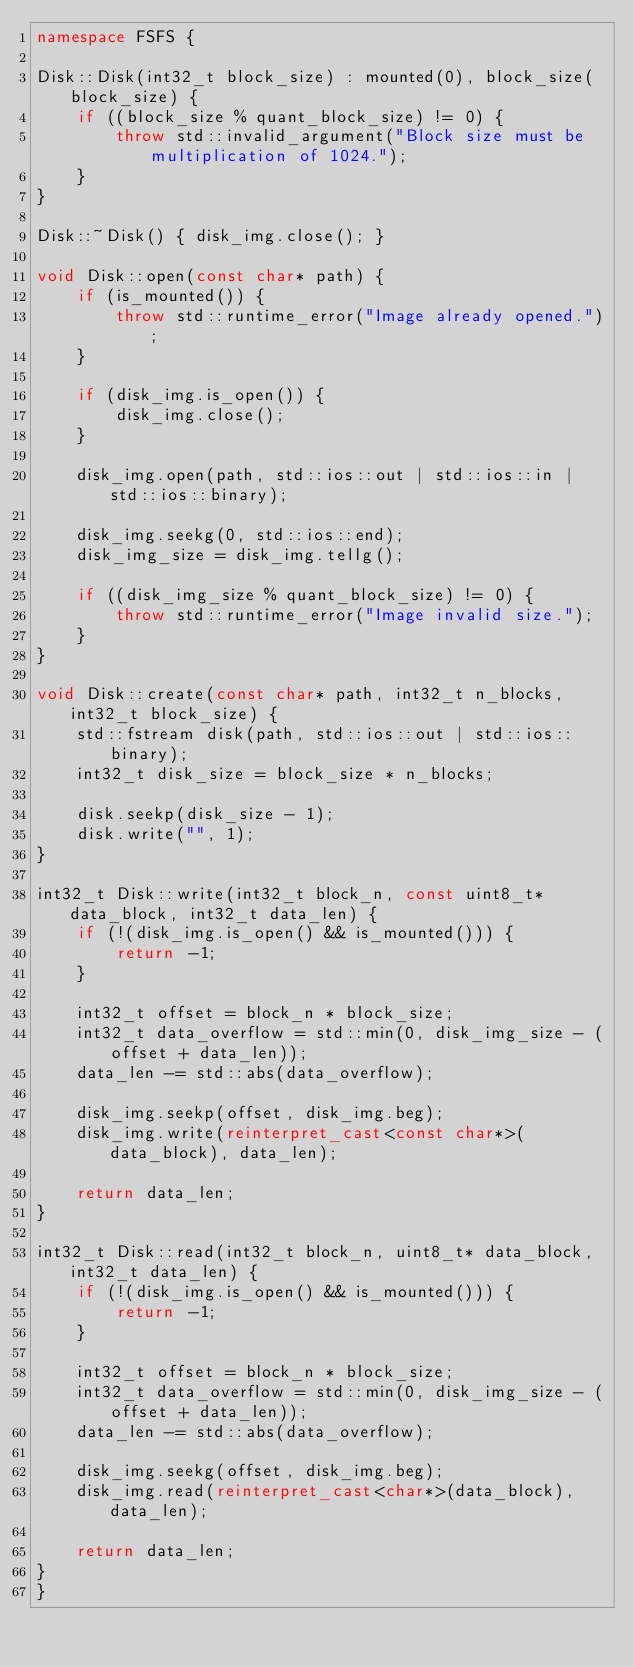Convert code to text. <code><loc_0><loc_0><loc_500><loc_500><_C++_>namespace FSFS {

Disk::Disk(int32_t block_size) : mounted(0), block_size(block_size) {
    if ((block_size % quant_block_size) != 0) {
        throw std::invalid_argument("Block size must be multiplication of 1024.");
    }
}

Disk::~Disk() { disk_img.close(); }

void Disk::open(const char* path) {
    if (is_mounted()) {
        throw std::runtime_error("Image already opened.");
    }

    if (disk_img.is_open()) {
        disk_img.close();
    }

    disk_img.open(path, std::ios::out | std::ios::in | std::ios::binary);

    disk_img.seekg(0, std::ios::end);
    disk_img_size = disk_img.tellg();

    if ((disk_img_size % quant_block_size) != 0) {
        throw std::runtime_error("Image invalid size.");
    }
}

void Disk::create(const char* path, int32_t n_blocks, int32_t block_size) {
    std::fstream disk(path, std::ios::out | std::ios::binary);
    int32_t disk_size = block_size * n_blocks;

    disk.seekp(disk_size - 1);
    disk.write("", 1);
}

int32_t Disk::write(int32_t block_n, const uint8_t* data_block, int32_t data_len) {
    if (!(disk_img.is_open() && is_mounted())) {
        return -1;
    }

    int32_t offset = block_n * block_size;
    int32_t data_overflow = std::min(0, disk_img_size - (offset + data_len));
    data_len -= std::abs(data_overflow);

    disk_img.seekp(offset, disk_img.beg);
    disk_img.write(reinterpret_cast<const char*>(data_block), data_len);

    return data_len;
}

int32_t Disk::read(int32_t block_n, uint8_t* data_block, int32_t data_len) {
    if (!(disk_img.is_open() && is_mounted())) {
        return -1;
    }

    int32_t offset = block_n * block_size;
    int32_t data_overflow = std::min(0, disk_img_size - (offset + data_len));
    data_len -= std::abs(data_overflow);

    disk_img.seekg(offset, disk_img.beg);
    disk_img.read(reinterpret_cast<char*>(data_block), data_len);

    return data_len;
}
}</code> 